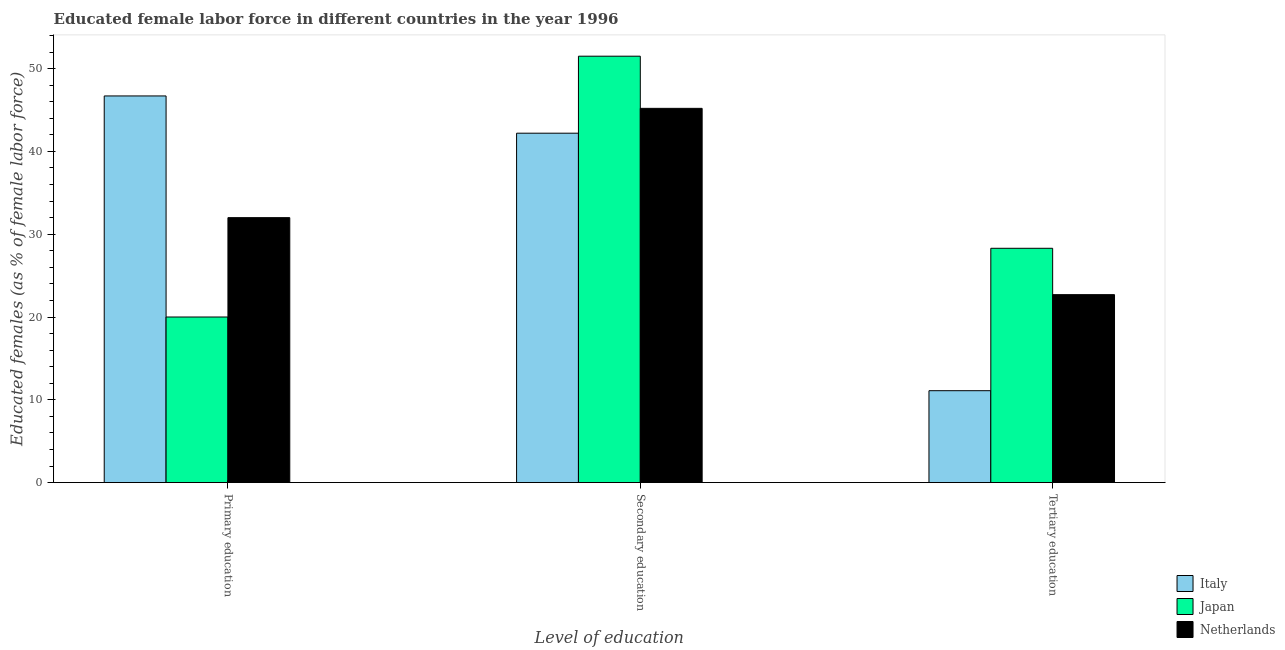How many different coloured bars are there?
Offer a very short reply. 3. Are the number of bars on each tick of the X-axis equal?
Keep it short and to the point. Yes. What is the label of the 3rd group of bars from the left?
Make the answer very short. Tertiary education. What is the percentage of female labor force who received primary education in Netherlands?
Keep it short and to the point. 32. Across all countries, what is the maximum percentage of female labor force who received secondary education?
Provide a succinct answer. 51.5. Across all countries, what is the minimum percentage of female labor force who received secondary education?
Make the answer very short. 42.2. What is the total percentage of female labor force who received primary education in the graph?
Give a very brief answer. 98.7. What is the difference between the percentage of female labor force who received primary education in Netherlands and that in Italy?
Provide a succinct answer. -14.7. What is the difference between the percentage of female labor force who received primary education in Japan and the percentage of female labor force who received secondary education in Italy?
Your response must be concise. -22.2. What is the average percentage of female labor force who received tertiary education per country?
Provide a succinct answer. 20.7. What is the difference between the percentage of female labor force who received primary education and percentage of female labor force who received secondary education in Netherlands?
Your answer should be very brief. -13.2. In how many countries, is the percentage of female labor force who received secondary education greater than 52 %?
Ensure brevity in your answer.  0. What is the ratio of the percentage of female labor force who received tertiary education in Italy to that in Netherlands?
Offer a very short reply. 0.49. Is the difference between the percentage of female labor force who received secondary education in Japan and Italy greater than the difference between the percentage of female labor force who received primary education in Japan and Italy?
Offer a very short reply. Yes. What is the difference between the highest and the second highest percentage of female labor force who received secondary education?
Offer a terse response. 6.3. What is the difference between the highest and the lowest percentage of female labor force who received primary education?
Give a very brief answer. 26.7. In how many countries, is the percentage of female labor force who received tertiary education greater than the average percentage of female labor force who received tertiary education taken over all countries?
Give a very brief answer. 2. Is the sum of the percentage of female labor force who received primary education in Japan and Italy greater than the maximum percentage of female labor force who received tertiary education across all countries?
Offer a very short reply. Yes. Is it the case that in every country, the sum of the percentage of female labor force who received primary education and percentage of female labor force who received secondary education is greater than the percentage of female labor force who received tertiary education?
Provide a succinct answer. Yes. How many countries are there in the graph?
Your answer should be compact. 3. What is the difference between two consecutive major ticks on the Y-axis?
Ensure brevity in your answer.  10. Are the values on the major ticks of Y-axis written in scientific E-notation?
Provide a succinct answer. No. How are the legend labels stacked?
Offer a terse response. Vertical. What is the title of the graph?
Make the answer very short. Educated female labor force in different countries in the year 1996. Does "Belize" appear as one of the legend labels in the graph?
Ensure brevity in your answer.  No. What is the label or title of the X-axis?
Your answer should be compact. Level of education. What is the label or title of the Y-axis?
Your response must be concise. Educated females (as % of female labor force). What is the Educated females (as % of female labor force) of Italy in Primary education?
Offer a very short reply. 46.7. What is the Educated females (as % of female labor force) in Italy in Secondary education?
Provide a succinct answer. 42.2. What is the Educated females (as % of female labor force) of Japan in Secondary education?
Your answer should be very brief. 51.5. What is the Educated females (as % of female labor force) of Netherlands in Secondary education?
Offer a terse response. 45.2. What is the Educated females (as % of female labor force) of Italy in Tertiary education?
Your answer should be compact. 11.1. What is the Educated females (as % of female labor force) of Japan in Tertiary education?
Make the answer very short. 28.3. What is the Educated females (as % of female labor force) in Netherlands in Tertiary education?
Your answer should be very brief. 22.7. Across all Level of education, what is the maximum Educated females (as % of female labor force) of Italy?
Your answer should be compact. 46.7. Across all Level of education, what is the maximum Educated females (as % of female labor force) of Japan?
Your response must be concise. 51.5. Across all Level of education, what is the maximum Educated females (as % of female labor force) in Netherlands?
Make the answer very short. 45.2. Across all Level of education, what is the minimum Educated females (as % of female labor force) in Italy?
Provide a succinct answer. 11.1. Across all Level of education, what is the minimum Educated females (as % of female labor force) of Japan?
Your answer should be very brief. 20. Across all Level of education, what is the minimum Educated females (as % of female labor force) in Netherlands?
Keep it short and to the point. 22.7. What is the total Educated females (as % of female labor force) in Italy in the graph?
Your answer should be very brief. 100. What is the total Educated females (as % of female labor force) of Japan in the graph?
Offer a very short reply. 99.8. What is the total Educated females (as % of female labor force) in Netherlands in the graph?
Your answer should be compact. 99.9. What is the difference between the Educated females (as % of female labor force) in Japan in Primary education and that in Secondary education?
Ensure brevity in your answer.  -31.5. What is the difference between the Educated females (as % of female labor force) in Italy in Primary education and that in Tertiary education?
Ensure brevity in your answer.  35.6. What is the difference between the Educated females (as % of female labor force) of Japan in Primary education and that in Tertiary education?
Keep it short and to the point. -8.3. What is the difference between the Educated females (as % of female labor force) of Netherlands in Primary education and that in Tertiary education?
Keep it short and to the point. 9.3. What is the difference between the Educated females (as % of female labor force) of Italy in Secondary education and that in Tertiary education?
Keep it short and to the point. 31.1. What is the difference between the Educated females (as % of female labor force) in Japan in Secondary education and that in Tertiary education?
Your response must be concise. 23.2. What is the difference between the Educated females (as % of female labor force) of Italy in Primary education and the Educated females (as % of female labor force) of Japan in Secondary education?
Provide a short and direct response. -4.8. What is the difference between the Educated females (as % of female labor force) of Italy in Primary education and the Educated females (as % of female labor force) of Netherlands in Secondary education?
Provide a short and direct response. 1.5. What is the difference between the Educated females (as % of female labor force) in Japan in Primary education and the Educated females (as % of female labor force) in Netherlands in Secondary education?
Offer a terse response. -25.2. What is the difference between the Educated females (as % of female labor force) in Italy in Primary education and the Educated females (as % of female labor force) in Netherlands in Tertiary education?
Provide a succinct answer. 24. What is the difference between the Educated females (as % of female labor force) of Italy in Secondary education and the Educated females (as % of female labor force) of Japan in Tertiary education?
Keep it short and to the point. 13.9. What is the difference between the Educated females (as % of female labor force) in Italy in Secondary education and the Educated females (as % of female labor force) in Netherlands in Tertiary education?
Offer a very short reply. 19.5. What is the difference between the Educated females (as % of female labor force) in Japan in Secondary education and the Educated females (as % of female labor force) in Netherlands in Tertiary education?
Offer a very short reply. 28.8. What is the average Educated females (as % of female labor force) in Italy per Level of education?
Provide a short and direct response. 33.33. What is the average Educated females (as % of female labor force) of Japan per Level of education?
Ensure brevity in your answer.  33.27. What is the average Educated females (as % of female labor force) in Netherlands per Level of education?
Give a very brief answer. 33.3. What is the difference between the Educated females (as % of female labor force) in Italy and Educated females (as % of female labor force) in Japan in Primary education?
Offer a terse response. 26.7. What is the difference between the Educated females (as % of female labor force) of Italy and Educated females (as % of female labor force) of Japan in Secondary education?
Your answer should be compact. -9.3. What is the difference between the Educated females (as % of female labor force) in Japan and Educated females (as % of female labor force) in Netherlands in Secondary education?
Your response must be concise. 6.3. What is the difference between the Educated females (as % of female labor force) in Italy and Educated females (as % of female labor force) in Japan in Tertiary education?
Give a very brief answer. -17.2. What is the difference between the Educated females (as % of female labor force) in Italy and Educated females (as % of female labor force) in Netherlands in Tertiary education?
Offer a terse response. -11.6. What is the difference between the Educated females (as % of female labor force) of Japan and Educated females (as % of female labor force) of Netherlands in Tertiary education?
Make the answer very short. 5.6. What is the ratio of the Educated females (as % of female labor force) of Italy in Primary education to that in Secondary education?
Ensure brevity in your answer.  1.11. What is the ratio of the Educated females (as % of female labor force) in Japan in Primary education to that in Secondary education?
Provide a short and direct response. 0.39. What is the ratio of the Educated females (as % of female labor force) in Netherlands in Primary education to that in Secondary education?
Offer a very short reply. 0.71. What is the ratio of the Educated females (as % of female labor force) of Italy in Primary education to that in Tertiary education?
Provide a succinct answer. 4.21. What is the ratio of the Educated females (as % of female labor force) in Japan in Primary education to that in Tertiary education?
Offer a terse response. 0.71. What is the ratio of the Educated females (as % of female labor force) in Netherlands in Primary education to that in Tertiary education?
Your answer should be very brief. 1.41. What is the ratio of the Educated females (as % of female labor force) of Italy in Secondary education to that in Tertiary education?
Keep it short and to the point. 3.8. What is the ratio of the Educated females (as % of female labor force) in Japan in Secondary education to that in Tertiary education?
Give a very brief answer. 1.82. What is the ratio of the Educated females (as % of female labor force) in Netherlands in Secondary education to that in Tertiary education?
Offer a terse response. 1.99. What is the difference between the highest and the second highest Educated females (as % of female labor force) in Italy?
Offer a very short reply. 4.5. What is the difference between the highest and the second highest Educated females (as % of female labor force) of Japan?
Offer a terse response. 23.2. What is the difference between the highest and the lowest Educated females (as % of female labor force) in Italy?
Give a very brief answer. 35.6. What is the difference between the highest and the lowest Educated females (as % of female labor force) of Japan?
Give a very brief answer. 31.5. What is the difference between the highest and the lowest Educated females (as % of female labor force) in Netherlands?
Provide a short and direct response. 22.5. 